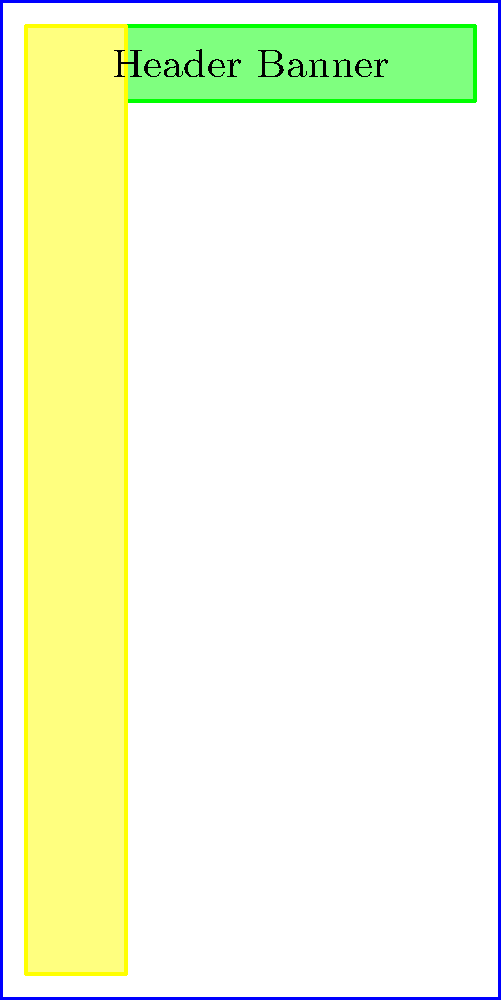As a digital marketer, which ad placement on this mock webpage layout would likely have the highest click-through rate (CTR) for a B2B software product? To determine the ad placement with the highest potential click-through rate (CTR) for a B2B software product, we need to consider several factors:

1. Visibility: Ad placements that are immediately visible without scrolling tend to perform better.
2. User intent: B2B audiences are typically looking for specific information or solutions.
3. Content relevance: Ads placed near relevant content are more likely to be clicked.
4. Ad blindness: Users tend to ignore certain areas of webpages where ads are commonly placed.

Let's analyze each placement:

A. Header Banner: Highly visible but often subject to banner blindness.
B. Sidebar: Visible without scrolling but may be ignored as users focus on main content.
C. In-content: Placed within the main content area, likely to be relevant to the user's interests.
D. Footer: Less visible as it requires scrolling to the bottom of the page.

For a B2B software product, the in-content ad (C) is likely to have the highest CTR because:
1. It's placed within the main content area where users are actively engaged.
2. It can be contextually relevant to the surrounding content.
3. It's less likely to be affected by ad blindness compared to header or sidebar placements.
4. B2B audiences are more likely to engage with ads that appear to be part of the content they're interested in.

While other placements have their merits, the in-content ad strikes the best balance between visibility and relevance for a B2B software product.
Answer: C (In-content ad placement) 